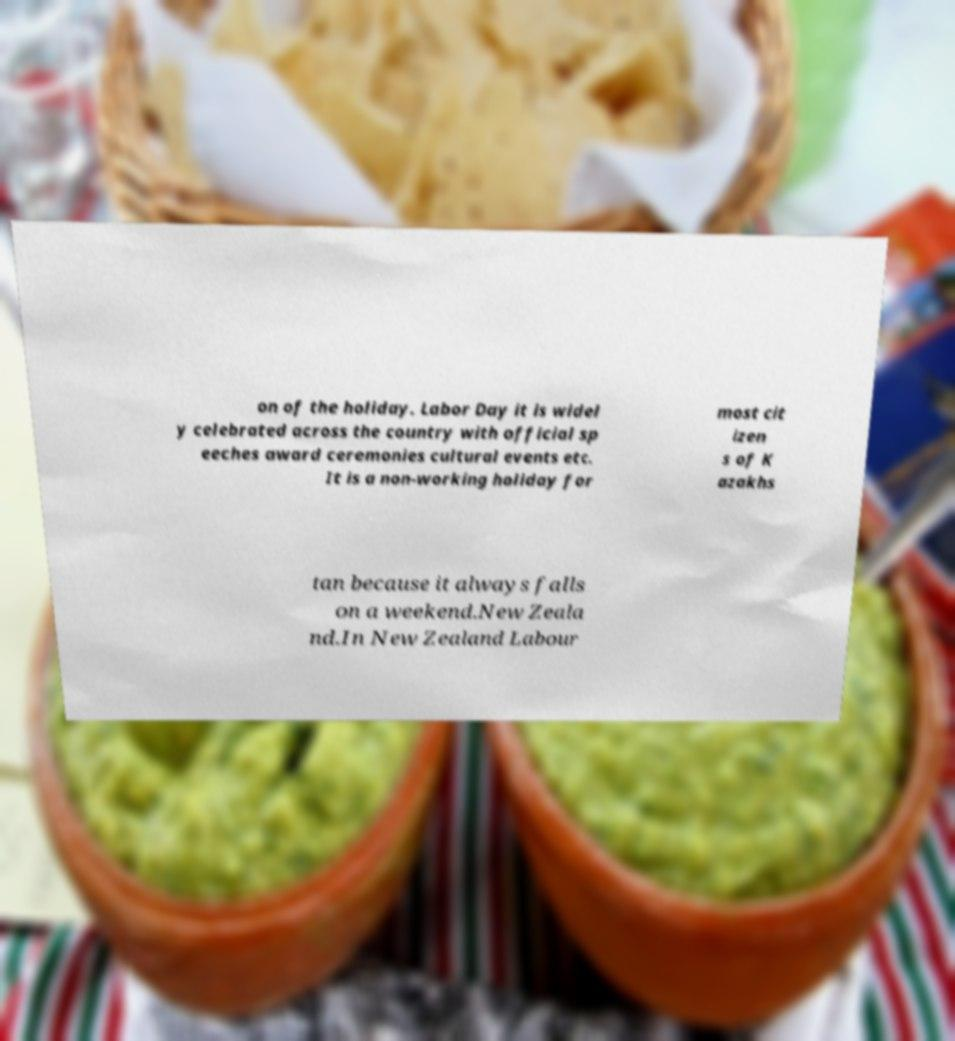Can you accurately transcribe the text from the provided image for me? on of the holiday. Labor Day it is widel y celebrated across the country with official sp eeches award ceremonies cultural events etc. It is a non-working holiday for most cit izen s of K azakhs tan because it always falls on a weekend.New Zeala nd.In New Zealand Labour 